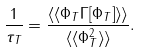Convert formula to latex. <formula><loc_0><loc_0><loc_500><loc_500>\frac { 1 } { \tau _ { T } } = \frac { \langle \langle \Phi _ { T } \Gamma [ \Phi _ { T } ] \rangle \rangle } { \langle \langle \Phi _ { T } ^ { 2 } \rangle \rangle } .</formula> 